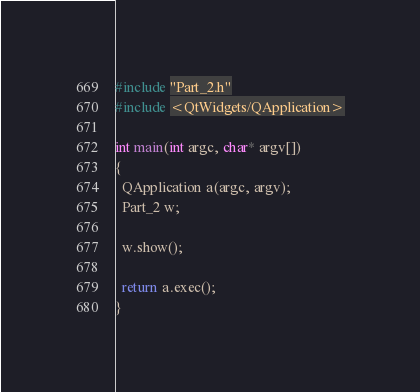<code> <loc_0><loc_0><loc_500><loc_500><_C++_>#include "Part_2.h"
#include <QtWidgets/QApplication>

int main(int argc, char* argv[])
{
  QApplication a(argc, argv);
  Part_2 w;

  w.show();

  return a.exec();
}
</code> 